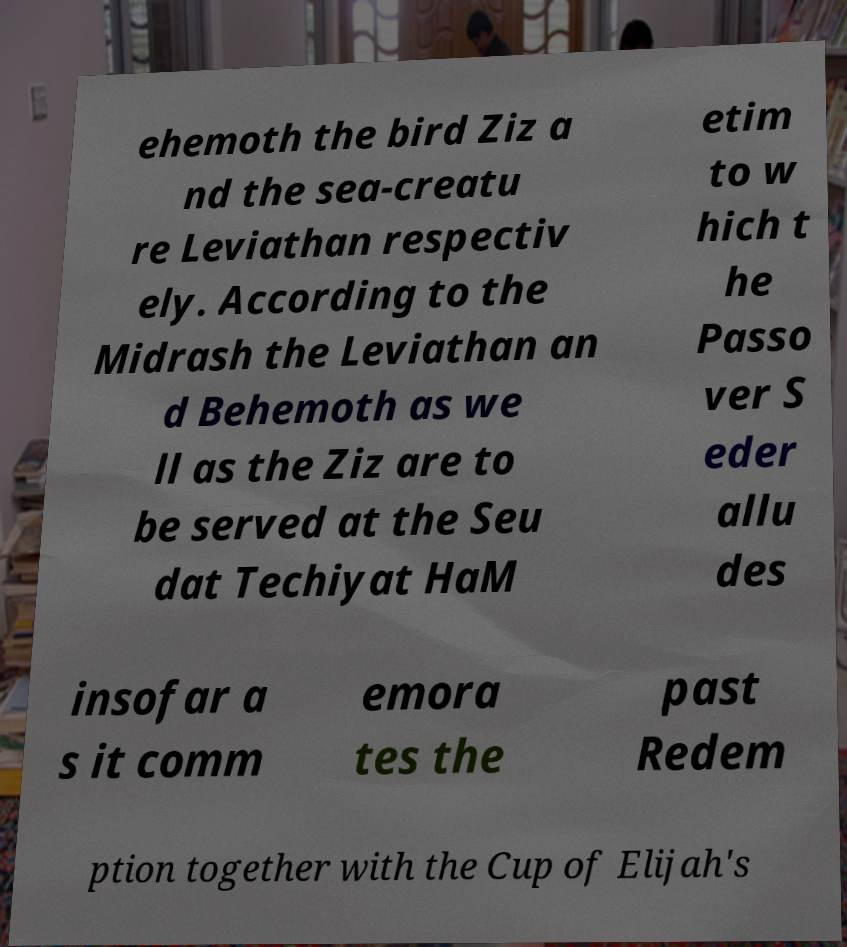Please identify and transcribe the text found in this image. ehemoth the bird Ziz a nd the sea-creatu re Leviathan respectiv ely. According to the Midrash the Leviathan an d Behemoth as we ll as the Ziz are to be served at the Seu dat Techiyat HaM etim to w hich t he Passo ver S eder allu des insofar a s it comm emora tes the past Redem ption together with the Cup of Elijah's 